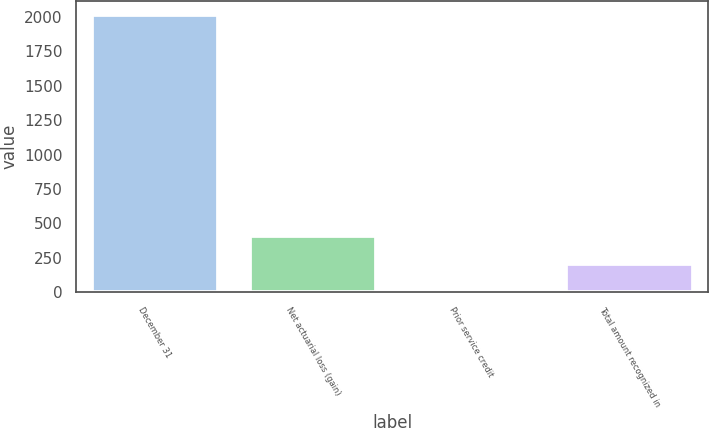<chart> <loc_0><loc_0><loc_500><loc_500><bar_chart><fcel>December 31<fcel>Net actuarial loss (gain)<fcel>Prior service credit<fcel>Total amount recognized in<nl><fcel>2016<fcel>408<fcel>6<fcel>207<nl></chart> 